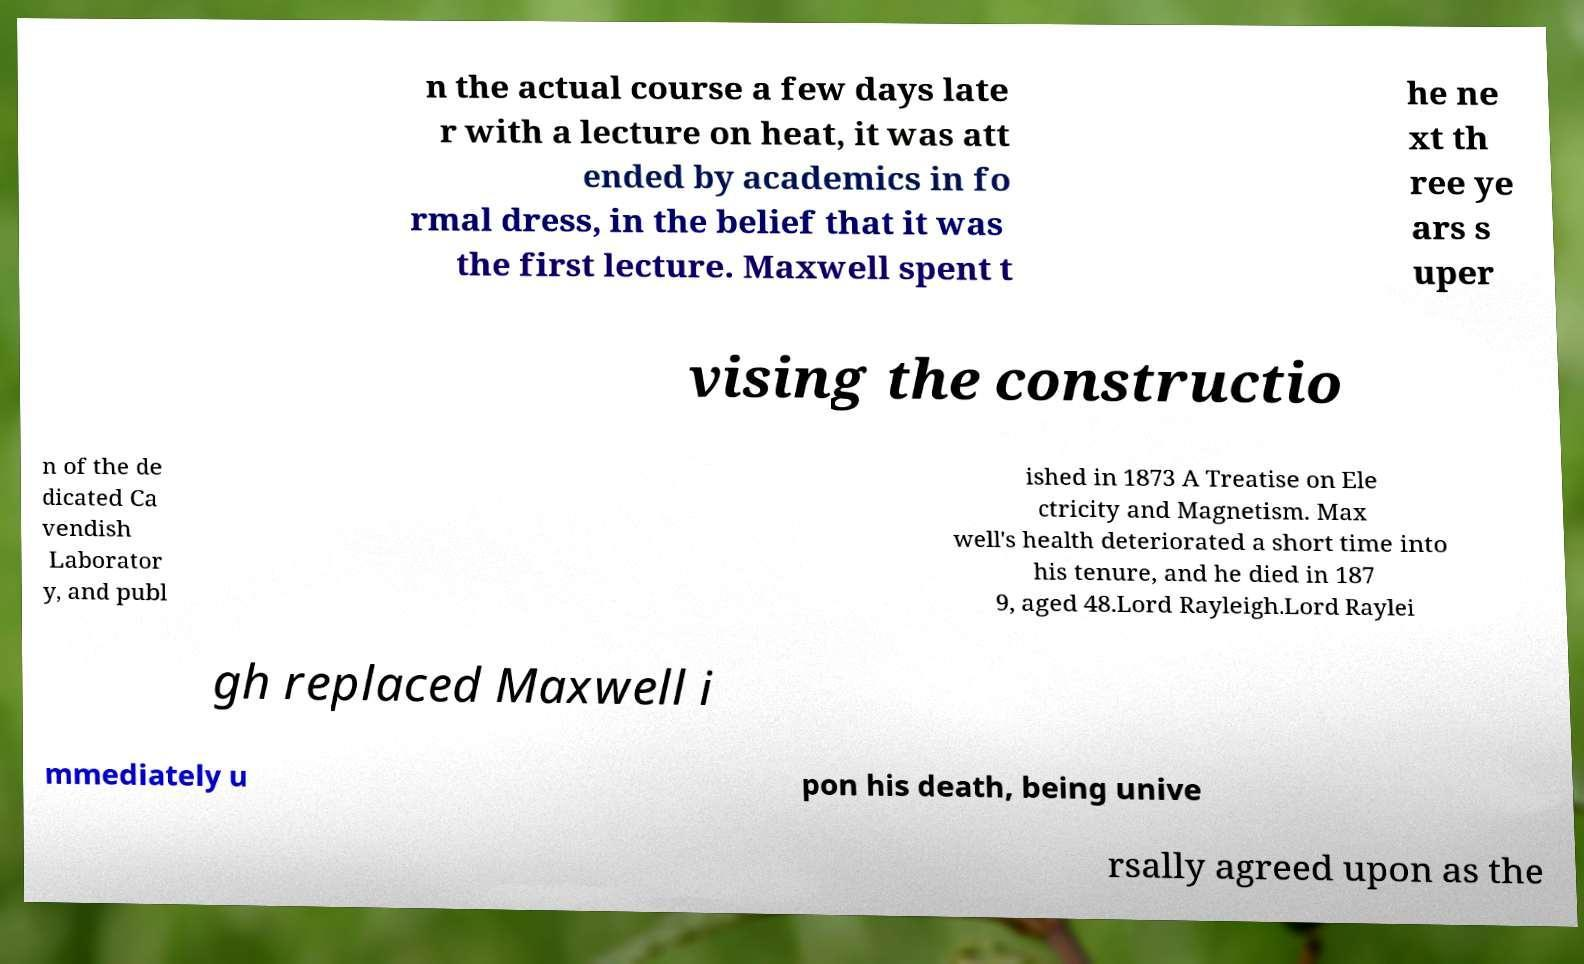There's text embedded in this image that I need extracted. Can you transcribe it verbatim? n the actual course a few days late r with a lecture on heat, it was att ended by academics in fo rmal dress, in the belief that it was the first lecture. Maxwell spent t he ne xt th ree ye ars s uper vising the constructio n of the de dicated Ca vendish Laborator y, and publ ished in 1873 A Treatise on Ele ctricity and Magnetism. Max well's health deteriorated a short time into his tenure, and he died in 187 9, aged 48.Lord Rayleigh.Lord Raylei gh replaced Maxwell i mmediately u pon his death, being unive rsally agreed upon as the 